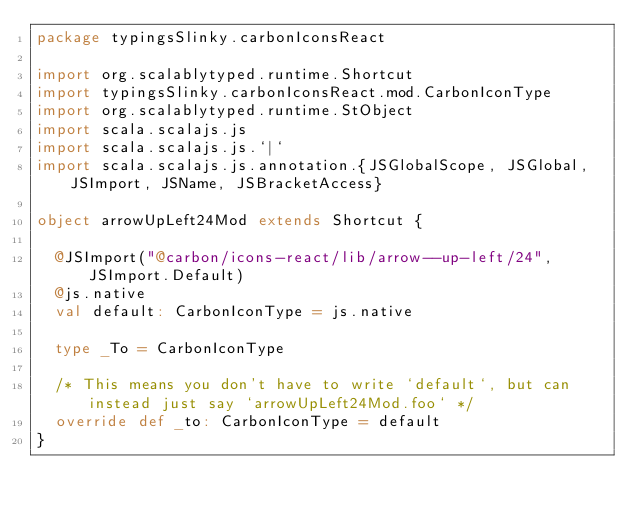<code> <loc_0><loc_0><loc_500><loc_500><_Scala_>package typingsSlinky.carbonIconsReact

import org.scalablytyped.runtime.Shortcut
import typingsSlinky.carbonIconsReact.mod.CarbonIconType
import org.scalablytyped.runtime.StObject
import scala.scalajs.js
import scala.scalajs.js.`|`
import scala.scalajs.js.annotation.{JSGlobalScope, JSGlobal, JSImport, JSName, JSBracketAccess}

object arrowUpLeft24Mod extends Shortcut {
  
  @JSImport("@carbon/icons-react/lib/arrow--up-left/24", JSImport.Default)
  @js.native
  val default: CarbonIconType = js.native
  
  type _To = CarbonIconType
  
  /* This means you don't have to write `default`, but can instead just say `arrowUpLeft24Mod.foo` */
  override def _to: CarbonIconType = default
}
</code> 